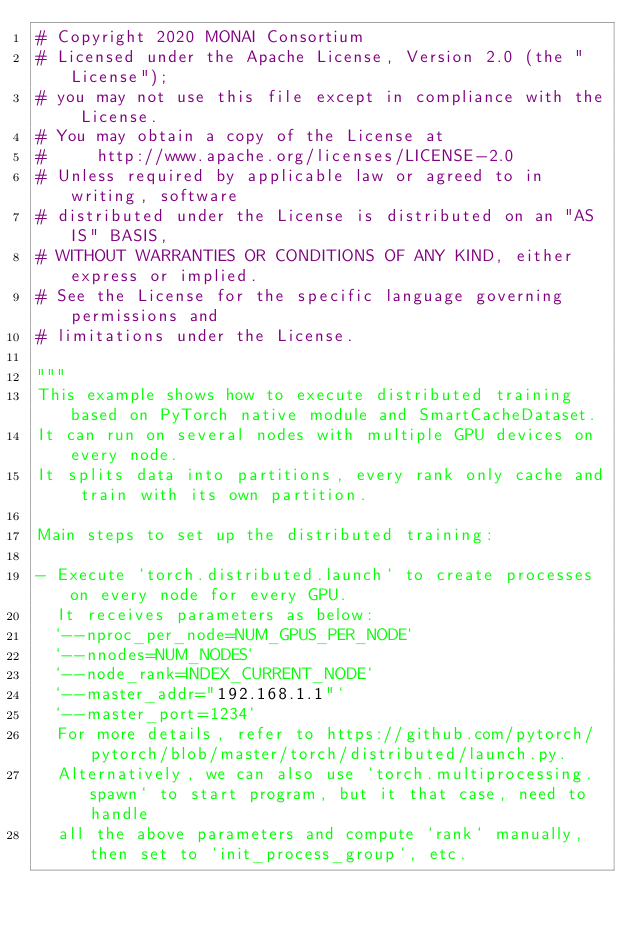Convert code to text. <code><loc_0><loc_0><loc_500><loc_500><_Python_># Copyright 2020 MONAI Consortium
# Licensed under the Apache License, Version 2.0 (the "License");
# you may not use this file except in compliance with the License.
# You may obtain a copy of the License at
#     http://www.apache.org/licenses/LICENSE-2.0
# Unless required by applicable law or agreed to in writing, software
# distributed under the License is distributed on an "AS IS" BASIS,
# WITHOUT WARRANTIES OR CONDITIONS OF ANY KIND, either express or implied.
# See the License for the specific language governing permissions and
# limitations under the License.

"""
This example shows how to execute distributed training based on PyTorch native module and SmartCacheDataset.
It can run on several nodes with multiple GPU devices on every node.
It splits data into partitions, every rank only cache and train with its own partition.

Main steps to set up the distributed training:

- Execute `torch.distributed.launch` to create processes on every node for every GPU.
  It receives parameters as below:
  `--nproc_per_node=NUM_GPUS_PER_NODE`
  `--nnodes=NUM_NODES`
  `--node_rank=INDEX_CURRENT_NODE`
  `--master_addr="192.168.1.1"`
  `--master_port=1234`
  For more details, refer to https://github.com/pytorch/pytorch/blob/master/torch/distributed/launch.py.
  Alternatively, we can also use `torch.multiprocessing.spawn` to start program, but it that case, need to handle
  all the above parameters and compute `rank` manually, then set to `init_process_group`, etc.</code> 